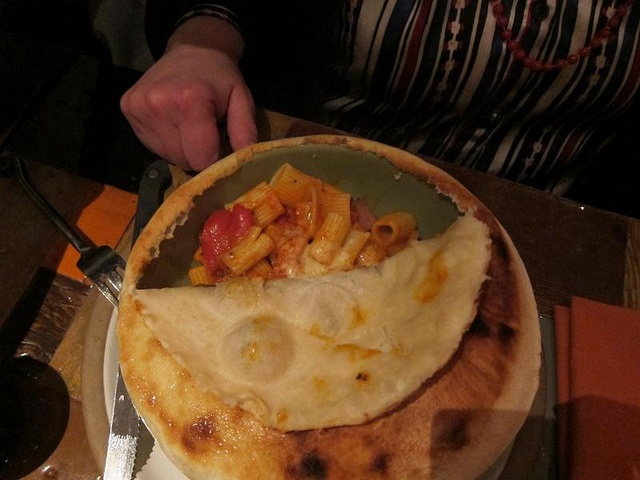Describe the objects in this image and their specific colors. I can see pizza in black, brown, tan, and maroon tones, people in black, maroon, and brown tones, dining table in black, maroon, brown, and darkgray tones, knife in black, lightgray, gray, and maroon tones, and fork in black, maroon, and gray tones in this image. 